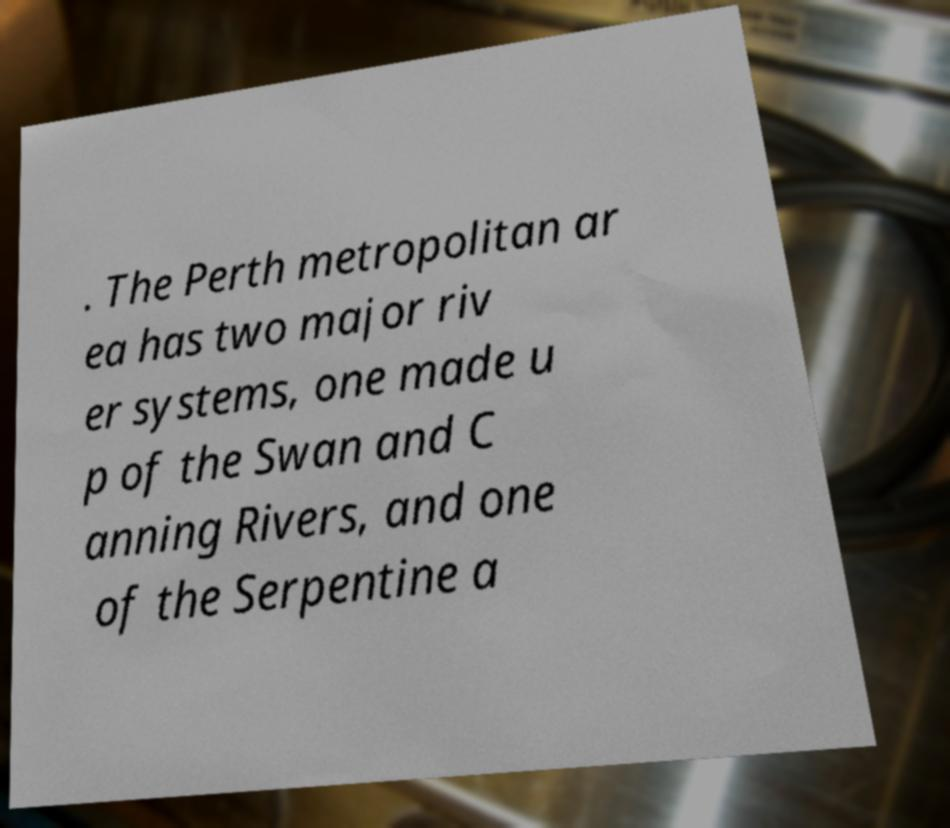What messages or text are displayed in this image? I need them in a readable, typed format. . The Perth metropolitan ar ea has two major riv er systems, one made u p of the Swan and C anning Rivers, and one of the Serpentine a 